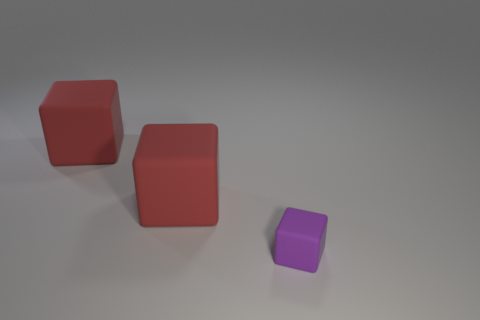Add 1 red blocks. How many objects exist? 4 Add 1 tiny matte things. How many tiny matte things exist? 2 Subtract 0 gray blocks. How many objects are left? 3 Subtract all purple cubes. Subtract all red objects. How many objects are left? 0 Add 1 red rubber cubes. How many red rubber cubes are left? 3 